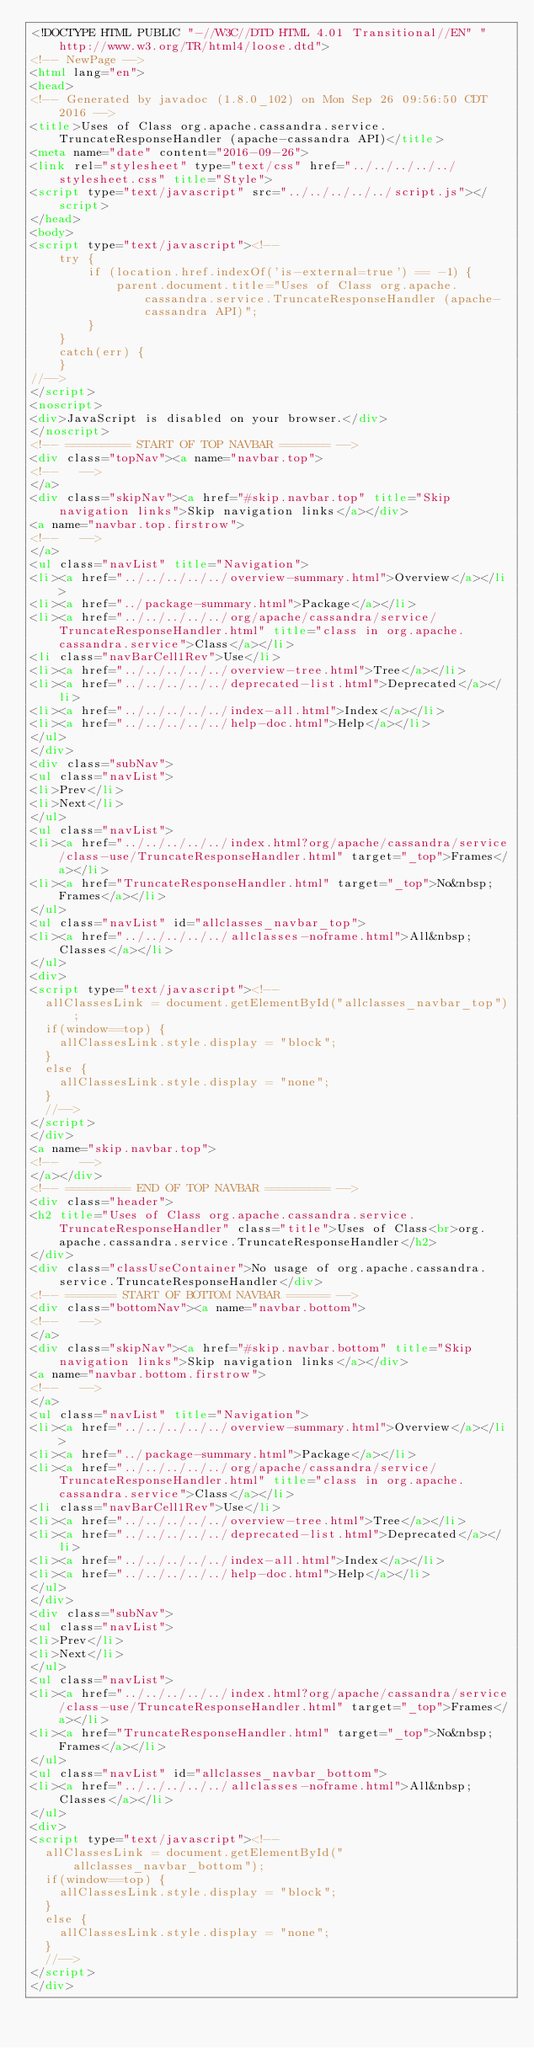Convert code to text. <code><loc_0><loc_0><loc_500><loc_500><_HTML_><!DOCTYPE HTML PUBLIC "-//W3C//DTD HTML 4.01 Transitional//EN" "http://www.w3.org/TR/html4/loose.dtd">
<!-- NewPage -->
<html lang="en">
<head>
<!-- Generated by javadoc (1.8.0_102) on Mon Sep 26 09:56:50 CDT 2016 -->
<title>Uses of Class org.apache.cassandra.service.TruncateResponseHandler (apache-cassandra API)</title>
<meta name="date" content="2016-09-26">
<link rel="stylesheet" type="text/css" href="../../../../../stylesheet.css" title="Style">
<script type="text/javascript" src="../../../../../script.js"></script>
</head>
<body>
<script type="text/javascript"><!--
    try {
        if (location.href.indexOf('is-external=true') == -1) {
            parent.document.title="Uses of Class org.apache.cassandra.service.TruncateResponseHandler (apache-cassandra API)";
        }
    }
    catch(err) {
    }
//-->
</script>
<noscript>
<div>JavaScript is disabled on your browser.</div>
</noscript>
<!-- ========= START OF TOP NAVBAR ======= -->
<div class="topNav"><a name="navbar.top">
<!--   -->
</a>
<div class="skipNav"><a href="#skip.navbar.top" title="Skip navigation links">Skip navigation links</a></div>
<a name="navbar.top.firstrow">
<!--   -->
</a>
<ul class="navList" title="Navigation">
<li><a href="../../../../../overview-summary.html">Overview</a></li>
<li><a href="../package-summary.html">Package</a></li>
<li><a href="../../../../../org/apache/cassandra/service/TruncateResponseHandler.html" title="class in org.apache.cassandra.service">Class</a></li>
<li class="navBarCell1Rev">Use</li>
<li><a href="../../../../../overview-tree.html">Tree</a></li>
<li><a href="../../../../../deprecated-list.html">Deprecated</a></li>
<li><a href="../../../../../index-all.html">Index</a></li>
<li><a href="../../../../../help-doc.html">Help</a></li>
</ul>
</div>
<div class="subNav">
<ul class="navList">
<li>Prev</li>
<li>Next</li>
</ul>
<ul class="navList">
<li><a href="../../../../../index.html?org/apache/cassandra/service/class-use/TruncateResponseHandler.html" target="_top">Frames</a></li>
<li><a href="TruncateResponseHandler.html" target="_top">No&nbsp;Frames</a></li>
</ul>
<ul class="navList" id="allclasses_navbar_top">
<li><a href="../../../../../allclasses-noframe.html">All&nbsp;Classes</a></li>
</ul>
<div>
<script type="text/javascript"><!--
  allClassesLink = document.getElementById("allclasses_navbar_top");
  if(window==top) {
    allClassesLink.style.display = "block";
  }
  else {
    allClassesLink.style.display = "none";
  }
  //-->
</script>
</div>
<a name="skip.navbar.top">
<!--   -->
</a></div>
<!-- ========= END OF TOP NAVBAR ========= -->
<div class="header">
<h2 title="Uses of Class org.apache.cassandra.service.TruncateResponseHandler" class="title">Uses of Class<br>org.apache.cassandra.service.TruncateResponseHandler</h2>
</div>
<div class="classUseContainer">No usage of org.apache.cassandra.service.TruncateResponseHandler</div>
<!-- ======= START OF BOTTOM NAVBAR ====== -->
<div class="bottomNav"><a name="navbar.bottom">
<!--   -->
</a>
<div class="skipNav"><a href="#skip.navbar.bottom" title="Skip navigation links">Skip navigation links</a></div>
<a name="navbar.bottom.firstrow">
<!--   -->
</a>
<ul class="navList" title="Navigation">
<li><a href="../../../../../overview-summary.html">Overview</a></li>
<li><a href="../package-summary.html">Package</a></li>
<li><a href="../../../../../org/apache/cassandra/service/TruncateResponseHandler.html" title="class in org.apache.cassandra.service">Class</a></li>
<li class="navBarCell1Rev">Use</li>
<li><a href="../../../../../overview-tree.html">Tree</a></li>
<li><a href="../../../../../deprecated-list.html">Deprecated</a></li>
<li><a href="../../../../../index-all.html">Index</a></li>
<li><a href="../../../../../help-doc.html">Help</a></li>
</ul>
</div>
<div class="subNav">
<ul class="navList">
<li>Prev</li>
<li>Next</li>
</ul>
<ul class="navList">
<li><a href="../../../../../index.html?org/apache/cassandra/service/class-use/TruncateResponseHandler.html" target="_top">Frames</a></li>
<li><a href="TruncateResponseHandler.html" target="_top">No&nbsp;Frames</a></li>
</ul>
<ul class="navList" id="allclasses_navbar_bottom">
<li><a href="../../../../../allclasses-noframe.html">All&nbsp;Classes</a></li>
</ul>
<div>
<script type="text/javascript"><!--
  allClassesLink = document.getElementById("allclasses_navbar_bottom");
  if(window==top) {
    allClassesLink.style.display = "block";
  }
  else {
    allClassesLink.style.display = "none";
  }
  //-->
</script>
</div></code> 